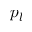Convert formula to latex. <formula><loc_0><loc_0><loc_500><loc_500>p _ { l }</formula> 